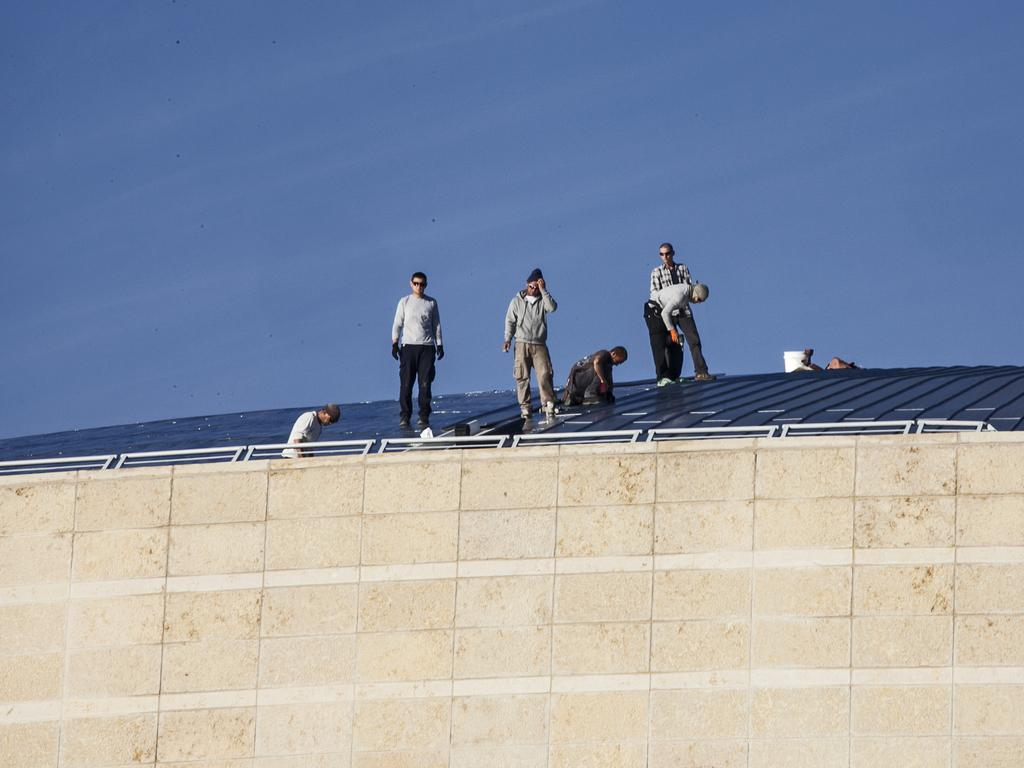What are the people in the image doing? The people in the image are standing on the top of a building. What is one person specifically doing? One person is fixing something. Can you describe the object behind the people? There is another object kept behind the people, but its details are not clear from the image. What type of cup can be seen being used to expand the wire in the image? There is no cup or wire present in the image, and therefore no such activity can be observed. 